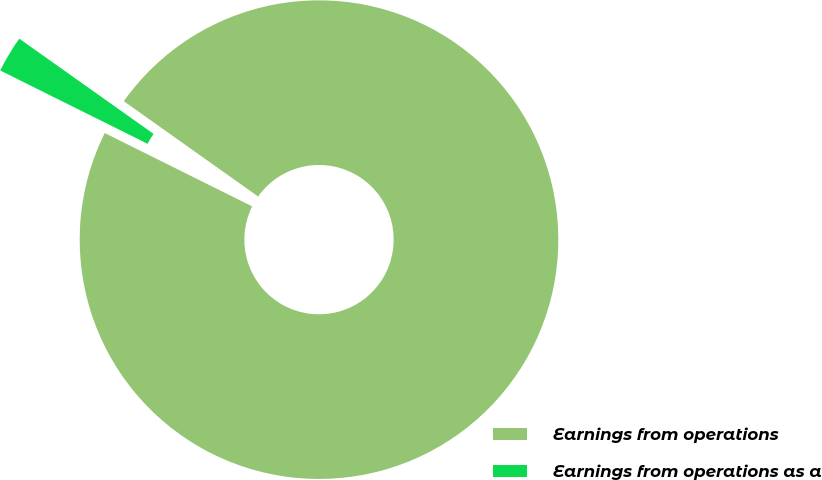Convert chart. <chart><loc_0><loc_0><loc_500><loc_500><pie_chart><fcel>Earnings from operations<fcel>Earnings from operations as a<nl><fcel>97.53%<fcel>2.47%<nl></chart> 